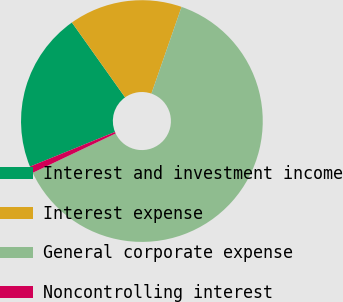<chart> <loc_0><loc_0><loc_500><loc_500><pie_chart><fcel>Interest and investment income<fcel>Interest expense<fcel>General corporate expense<fcel>Noncontrolling interest<nl><fcel>21.33%<fcel>15.15%<fcel>62.63%<fcel>0.89%<nl></chart> 